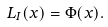Convert formula to latex. <formula><loc_0><loc_0><loc_500><loc_500>L _ { I } ( x ) = \Phi ( x ) .</formula> 